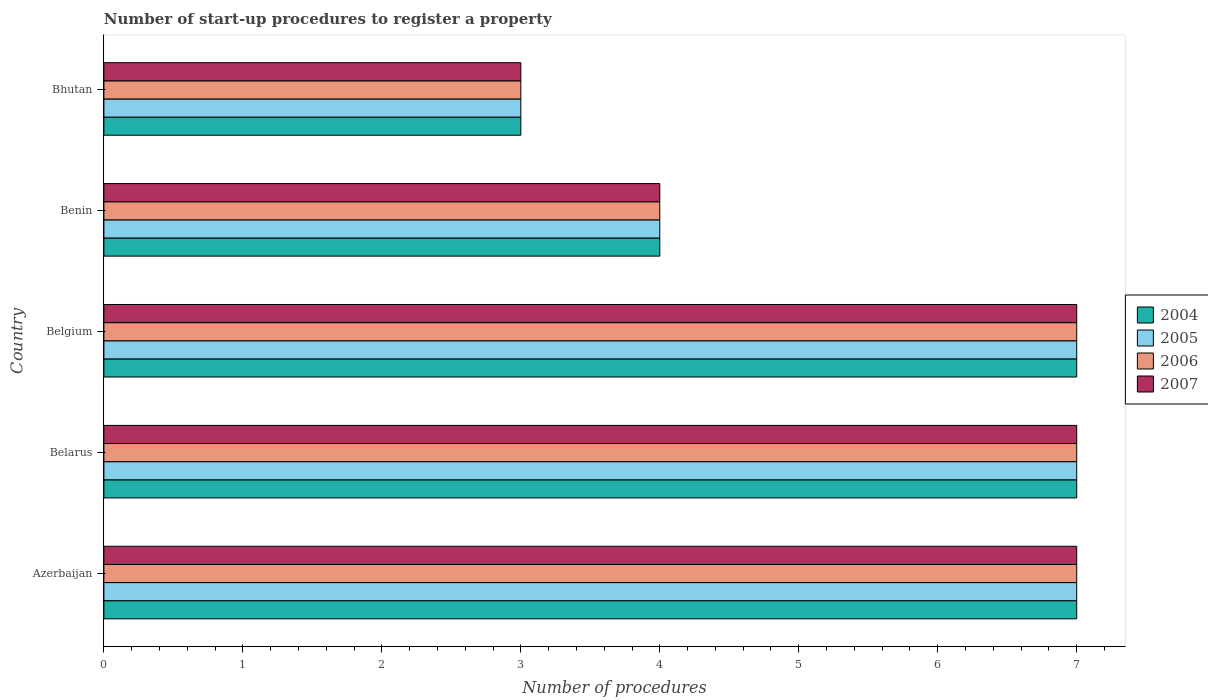How many different coloured bars are there?
Your response must be concise. 4. How many bars are there on the 5th tick from the top?
Ensure brevity in your answer.  4. How many bars are there on the 4th tick from the bottom?
Your answer should be compact. 4. What is the label of the 4th group of bars from the top?
Your response must be concise. Belarus. Across all countries, what is the minimum number of procedures required to register a property in 2004?
Your answer should be very brief. 3. In which country was the number of procedures required to register a property in 2005 maximum?
Offer a terse response. Azerbaijan. In which country was the number of procedures required to register a property in 2006 minimum?
Ensure brevity in your answer.  Bhutan. What is the total number of procedures required to register a property in 2004 in the graph?
Your response must be concise. 28. What is the difference between the number of procedures required to register a property in 2005 in Benin and that in Bhutan?
Keep it short and to the point. 1. What is the difference between the number of procedures required to register a property in 2005 and number of procedures required to register a property in 2006 in Belgium?
Make the answer very short. 0. In how many countries, is the number of procedures required to register a property in 2004 greater than 5.6 ?
Offer a terse response. 3. What is the ratio of the number of procedures required to register a property in 2007 in Belarus to that in Benin?
Give a very brief answer. 1.75. Is the difference between the number of procedures required to register a property in 2005 in Belarus and Bhutan greater than the difference between the number of procedures required to register a property in 2006 in Belarus and Bhutan?
Keep it short and to the point. No. What is the difference between the highest and the second highest number of procedures required to register a property in 2004?
Ensure brevity in your answer.  0. What is the difference between the highest and the lowest number of procedures required to register a property in 2005?
Your answer should be compact. 4. In how many countries, is the number of procedures required to register a property in 2005 greater than the average number of procedures required to register a property in 2005 taken over all countries?
Provide a succinct answer. 3. What does the 3rd bar from the bottom in Belarus represents?
Your response must be concise. 2006. Are all the bars in the graph horizontal?
Provide a short and direct response. Yes. How many countries are there in the graph?
Your answer should be very brief. 5. Are the values on the major ticks of X-axis written in scientific E-notation?
Your answer should be compact. No. Where does the legend appear in the graph?
Offer a terse response. Center right. How many legend labels are there?
Your answer should be very brief. 4. How are the legend labels stacked?
Ensure brevity in your answer.  Vertical. What is the title of the graph?
Provide a short and direct response. Number of start-up procedures to register a property. Does "1969" appear as one of the legend labels in the graph?
Your response must be concise. No. What is the label or title of the X-axis?
Your response must be concise. Number of procedures. What is the label or title of the Y-axis?
Ensure brevity in your answer.  Country. What is the Number of procedures in 2005 in Azerbaijan?
Provide a short and direct response. 7. What is the Number of procedures of 2006 in Azerbaijan?
Ensure brevity in your answer.  7. What is the Number of procedures of 2007 in Azerbaijan?
Your answer should be compact. 7. What is the Number of procedures in 2004 in Belarus?
Your answer should be very brief. 7. What is the Number of procedures of 2004 in Belgium?
Your answer should be compact. 7. What is the Number of procedures of 2006 in Belgium?
Offer a terse response. 7. What is the Number of procedures in 2007 in Belgium?
Your answer should be compact. 7. What is the Number of procedures of 2004 in Bhutan?
Offer a very short reply. 3. What is the Number of procedures in 2005 in Bhutan?
Ensure brevity in your answer.  3. What is the Number of procedures in 2006 in Bhutan?
Make the answer very short. 3. Across all countries, what is the maximum Number of procedures in 2004?
Your response must be concise. 7. Across all countries, what is the maximum Number of procedures of 2006?
Provide a succinct answer. 7. What is the total Number of procedures in 2005 in the graph?
Make the answer very short. 28. What is the total Number of procedures in 2007 in the graph?
Offer a terse response. 28. What is the difference between the Number of procedures in 2004 in Azerbaijan and that in Belarus?
Ensure brevity in your answer.  0. What is the difference between the Number of procedures in 2007 in Azerbaijan and that in Belarus?
Your answer should be compact. 0. What is the difference between the Number of procedures in 2004 in Azerbaijan and that in Belgium?
Your answer should be compact. 0. What is the difference between the Number of procedures in 2005 in Azerbaijan and that in Belgium?
Make the answer very short. 0. What is the difference between the Number of procedures in 2004 in Azerbaijan and that in Bhutan?
Make the answer very short. 4. What is the difference between the Number of procedures in 2007 in Belarus and that in Belgium?
Your answer should be very brief. 0. What is the difference between the Number of procedures in 2004 in Belarus and that in Benin?
Make the answer very short. 3. What is the difference between the Number of procedures in 2006 in Belarus and that in Bhutan?
Your answer should be compact. 4. What is the difference between the Number of procedures of 2007 in Belarus and that in Bhutan?
Make the answer very short. 4. What is the difference between the Number of procedures of 2004 in Belgium and that in Benin?
Your answer should be very brief. 3. What is the difference between the Number of procedures of 2005 in Belgium and that in Benin?
Provide a short and direct response. 3. What is the difference between the Number of procedures in 2007 in Belgium and that in Benin?
Keep it short and to the point. 3. What is the difference between the Number of procedures of 2005 in Belgium and that in Bhutan?
Provide a short and direct response. 4. What is the difference between the Number of procedures in 2006 in Belgium and that in Bhutan?
Ensure brevity in your answer.  4. What is the difference between the Number of procedures in 2007 in Belgium and that in Bhutan?
Keep it short and to the point. 4. What is the difference between the Number of procedures of 2004 in Benin and that in Bhutan?
Ensure brevity in your answer.  1. What is the difference between the Number of procedures of 2006 in Benin and that in Bhutan?
Offer a very short reply. 1. What is the difference between the Number of procedures of 2004 in Azerbaijan and the Number of procedures of 2007 in Belarus?
Keep it short and to the point. 0. What is the difference between the Number of procedures of 2005 in Azerbaijan and the Number of procedures of 2006 in Belarus?
Keep it short and to the point. 0. What is the difference between the Number of procedures of 2004 in Azerbaijan and the Number of procedures of 2005 in Belgium?
Give a very brief answer. 0. What is the difference between the Number of procedures in 2004 in Azerbaijan and the Number of procedures in 2006 in Belgium?
Provide a short and direct response. 0. What is the difference between the Number of procedures in 2005 in Azerbaijan and the Number of procedures in 2006 in Belgium?
Your response must be concise. 0. What is the difference between the Number of procedures of 2005 in Azerbaijan and the Number of procedures of 2007 in Belgium?
Ensure brevity in your answer.  0. What is the difference between the Number of procedures of 2006 in Azerbaijan and the Number of procedures of 2007 in Belgium?
Your answer should be compact. 0. What is the difference between the Number of procedures in 2004 in Azerbaijan and the Number of procedures in 2007 in Benin?
Your answer should be very brief. 3. What is the difference between the Number of procedures in 2005 in Azerbaijan and the Number of procedures in 2006 in Benin?
Keep it short and to the point. 3. What is the difference between the Number of procedures of 2005 in Azerbaijan and the Number of procedures of 2007 in Benin?
Offer a very short reply. 3. What is the difference between the Number of procedures of 2004 in Azerbaijan and the Number of procedures of 2006 in Bhutan?
Your answer should be compact. 4. What is the difference between the Number of procedures of 2005 in Azerbaijan and the Number of procedures of 2006 in Bhutan?
Offer a very short reply. 4. What is the difference between the Number of procedures of 2006 in Azerbaijan and the Number of procedures of 2007 in Bhutan?
Offer a terse response. 4. What is the difference between the Number of procedures of 2005 in Belarus and the Number of procedures of 2007 in Belgium?
Provide a short and direct response. 0. What is the difference between the Number of procedures of 2004 in Belarus and the Number of procedures of 2006 in Benin?
Offer a very short reply. 3. What is the difference between the Number of procedures of 2004 in Belarus and the Number of procedures of 2007 in Benin?
Provide a short and direct response. 3. What is the difference between the Number of procedures of 2006 in Belarus and the Number of procedures of 2007 in Benin?
Give a very brief answer. 3. What is the difference between the Number of procedures of 2004 in Belarus and the Number of procedures of 2006 in Bhutan?
Provide a succinct answer. 4. What is the difference between the Number of procedures of 2004 in Belarus and the Number of procedures of 2007 in Bhutan?
Keep it short and to the point. 4. What is the difference between the Number of procedures of 2005 in Belarus and the Number of procedures of 2006 in Bhutan?
Keep it short and to the point. 4. What is the difference between the Number of procedures of 2005 in Belarus and the Number of procedures of 2007 in Bhutan?
Make the answer very short. 4. What is the difference between the Number of procedures in 2006 in Belarus and the Number of procedures in 2007 in Bhutan?
Your response must be concise. 4. What is the difference between the Number of procedures in 2004 in Belgium and the Number of procedures in 2006 in Benin?
Your response must be concise. 3. What is the difference between the Number of procedures of 2005 in Belgium and the Number of procedures of 2007 in Benin?
Your answer should be compact. 3. What is the difference between the Number of procedures of 2004 in Belgium and the Number of procedures of 2005 in Bhutan?
Provide a succinct answer. 4. What is the difference between the Number of procedures of 2004 in Belgium and the Number of procedures of 2007 in Bhutan?
Your answer should be compact. 4. What is the difference between the Number of procedures in 2006 in Belgium and the Number of procedures in 2007 in Bhutan?
Make the answer very short. 4. What is the difference between the Number of procedures of 2004 in Benin and the Number of procedures of 2005 in Bhutan?
Give a very brief answer. 1. What is the difference between the Number of procedures of 2004 in Benin and the Number of procedures of 2006 in Bhutan?
Your answer should be very brief. 1. What is the difference between the Number of procedures in 2004 in Benin and the Number of procedures in 2007 in Bhutan?
Your answer should be very brief. 1. What is the difference between the Number of procedures of 2005 in Benin and the Number of procedures of 2007 in Bhutan?
Your response must be concise. 1. What is the difference between the Number of procedures in 2006 in Benin and the Number of procedures in 2007 in Bhutan?
Provide a succinct answer. 1. What is the average Number of procedures of 2004 per country?
Provide a short and direct response. 5.6. What is the average Number of procedures of 2005 per country?
Ensure brevity in your answer.  5.6. What is the difference between the Number of procedures in 2004 and Number of procedures in 2005 in Azerbaijan?
Make the answer very short. 0. What is the difference between the Number of procedures of 2004 and Number of procedures of 2006 in Azerbaijan?
Make the answer very short. 0. What is the difference between the Number of procedures in 2004 and Number of procedures in 2007 in Azerbaijan?
Make the answer very short. 0. What is the difference between the Number of procedures in 2005 and Number of procedures in 2007 in Azerbaijan?
Ensure brevity in your answer.  0. What is the difference between the Number of procedures of 2006 and Number of procedures of 2007 in Azerbaijan?
Offer a very short reply. 0. What is the difference between the Number of procedures of 2004 and Number of procedures of 2005 in Belarus?
Your response must be concise. 0. What is the difference between the Number of procedures of 2004 and Number of procedures of 2006 in Belarus?
Your response must be concise. 0. What is the difference between the Number of procedures in 2004 and Number of procedures in 2007 in Belarus?
Offer a very short reply. 0. What is the difference between the Number of procedures in 2005 and Number of procedures in 2006 in Belarus?
Your response must be concise. 0. What is the difference between the Number of procedures in 2005 and Number of procedures in 2007 in Belarus?
Make the answer very short. 0. What is the difference between the Number of procedures of 2005 and Number of procedures of 2006 in Belgium?
Your response must be concise. 0. What is the difference between the Number of procedures of 2005 and Number of procedures of 2007 in Belgium?
Ensure brevity in your answer.  0. What is the difference between the Number of procedures in 2005 and Number of procedures in 2006 in Benin?
Your answer should be very brief. 0. What is the difference between the Number of procedures in 2005 and Number of procedures in 2007 in Benin?
Keep it short and to the point. 0. What is the difference between the Number of procedures in 2006 and Number of procedures in 2007 in Benin?
Provide a succinct answer. 0. What is the difference between the Number of procedures of 2004 and Number of procedures of 2006 in Bhutan?
Your answer should be compact. 0. What is the difference between the Number of procedures in 2004 and Number of procedures in 2007 in Bhutan?
Keep it short and to the point. 0. What is the difference between the Number of procedures of 2005 and Number of procedures of 2006 in Bhutan?
Provide a succinct answer. 0. What is the difference between the Number of procedures in 2005 and Number of procedures in 2007 in Bhutan?
Offer a terse response. 0. What is the difference between the Number of procedures in 2006 and Number of procedures in 2007 in Bhutan?
Make the answer very short. 0. What is the ratio of the Number of procedures of 2005 in Azerbaijan to that in Belarus?
Offer a terse response. 1. What is the ratio of the Number of procedures in 2005 in Azerbaijan to that in Belgium?
Offer a terse response. 1. What is the ratio of the Number of procedures in 2007 in Azerbaijan to that in Belgium?
Your response must be concise. 1. What is the ratio of the Number of procedures in 2004 in Azerbaijan to that in Benin?
Offer a terse response. 1.75. What is the ratio of the Number of procedures of 2005 in Azerbaijan to that in Benin?
Provide a succinct answer. 1.75. What is the ratio of the Number of procedures of 2006 in Azerbaijan to that in Benin?
Ensure brevity in your answer.  1.75. What is the ratio of the Number of procedures in 2004 in Azerbaijan to that in Bhutan?
Provide a succinct answer. 2.33. What is the ratio of the Number of procedures of 2005 in Azerbaijan to that in Bhutan?
Your answer should be very brief. 2.33. What is the ratio of the Number of procedures in 2006 in Azerbaijan to that in Bhutan?
Offer a terse response. 2.33. What is the ratio of the Number of procedures of 2007 in Azerbaijan to that in Bhutan?
Your response must be concise. 2.33. What is the ratio of the Number of procedures of 2004 in Belarus to that in Belgium?
Your answer should be compact. 1. What is the ratio of the Number of procedures in 2005 in Belarus to that in Belgium?
Offer a terse response. 1. What is the ratio of the Number of procedures in 2006 in Belarus to that in Benin?
Offer a very short reply. 1.75. What is the ratio of the Number of procedures in 2004 in Belarus to that in Bhutan?
Your response must be concise. 2.33. What is the ratio of the Number of procedures in 2005 in Belarus to that in Bhutan?
Your answer should be very brief. 2.33. What is the ratio of the Number of procedures of 2006 in Belarus to that in Bhutan?
Give a very brief answer. 2.33. What is the ratio of the Number of procedures of 2007 in Belarus to that in Bhutan?
Your answer should be compact. 2.33. What is the ratio of the Number of procedures in 2007 in Belgium to that in Benin?
Your response must be concise. 1.75. What is the ratio of the Number of procedures of 2004 in Belgium to that in Bhutan?
Ensure brevity in your answer.  2.33. What is the ratio of the Number of procedures of 2005 in Belgium to that in Bhutan?
Make the answer very short. 2.33. What is the ratio of the Number of procedures in 2006 in Belgium to that in Bhutan?
Your answer should be compact. 2.33. What is the ratio of the Number of procedures of 2007 in Belgium to that in Bhutan?
Your response must be concise. 2.33. What is the ratio of the Number of procedures of 2004 in Benin to that in Bhutan?
Ensure brevity in your answer.  1.33. What is the ratio of the Number of procedures in 2006 in Benin to that in Bhutan?
Make the answer very short. 1.33. What is the ratio of the Number of procedures in 2007 in Benin to that in Bhutan?
Provide a succinct answer. 1.33. What is the difference between the highest and the second highest Number of procedures in 2005?
Ensure brevity in your answer.  0. What is the difference between the highest and the lowest Number of procedures of 2004?
Make the answer very short. 4. What is the difference between the highest and the lowest Number of procedures of 2006?
Provide a short and direct response. 4. 